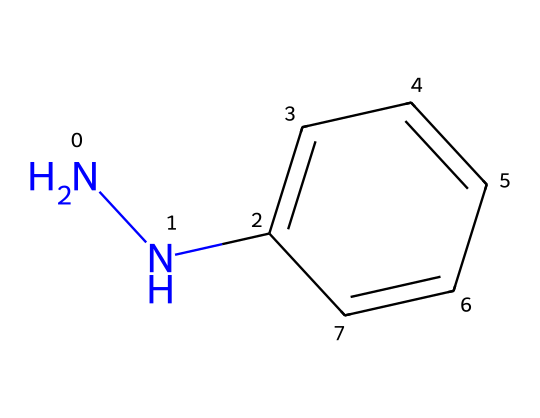What is the name of this chemical? The SMILES representation corresponds to a compound with the structure containing a phenyl group (C1=CC=CC=C1) and a hydrazine (N-N) moiety. Therefore, the name based on its structural features is phenylhydrazine.
Answer: phenylhydrazine How many nitrogen atoms are present in phenylhydrazine? In the provided SMILES, "N" appears twice, indicating there are two nitrogen atoms in the structure of phenylhydrazine.
Answer: 2 What is the functional group present in phenylhydrazine? The presence of the N-N connection, typical of hydrazines, indicates that the functional group in this molecule is a hydrazine group.
Answer: hydrazine What type of isomerism can phenylhydrazine exhibit? Given the molecular structure, phenylhydrazine can exhibit geometric isomerism because of the restricted rotation around the N-N bond.
Answer: geometric How many carbon atoms are in phenylhydrazine? Analyzing the SMILES representation, there are six carbon atoms in the phenyl ring and one in the hydrazine moiety, making a total of seven carbon atoms in phenylhydrazine.
Answer: 7 What property makes phenylhydrazine a useful reagent in organic synthesis? The hydrazine functional group allows it to form stable hydrazones with carbonyl compounds, which is a key property for its use in organic synthesis.
Answer: forms hydrazones What reaction type is commonly associated with phenylhydrazine? Due to its ability to react with aldehydes and ketones to form hydrazones, condensation reactions are commonly associated with phenylhydrazine.
Answer: condensation 